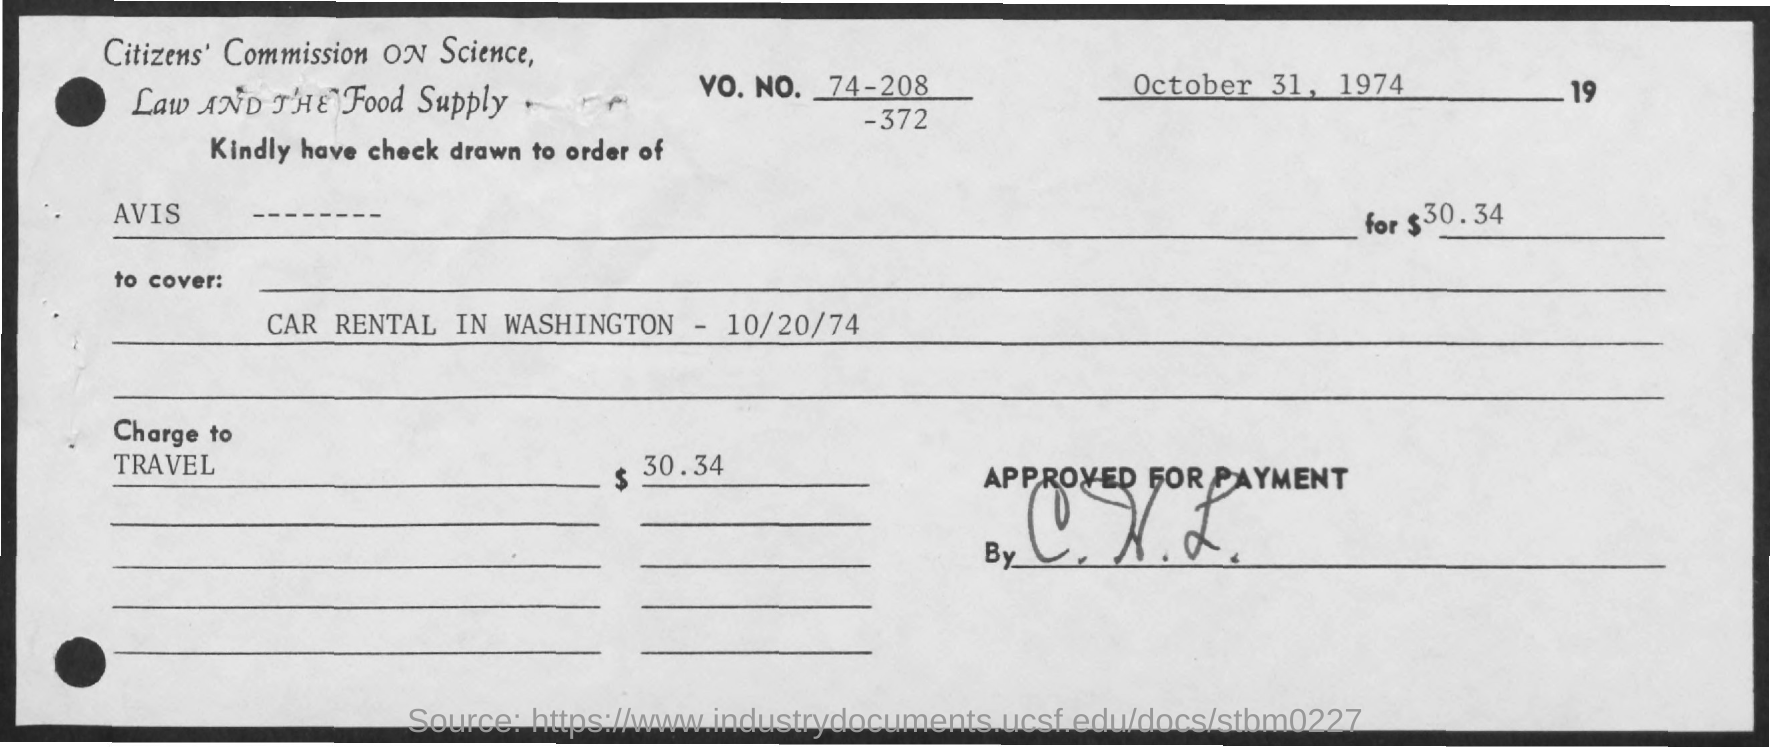How much is the charge to travel ?
Offer a very short reply. $ 30.34. What is written in the to cover ?
Ensure brevity in your answer.  Car Rental in Washington - 10/20/74. 